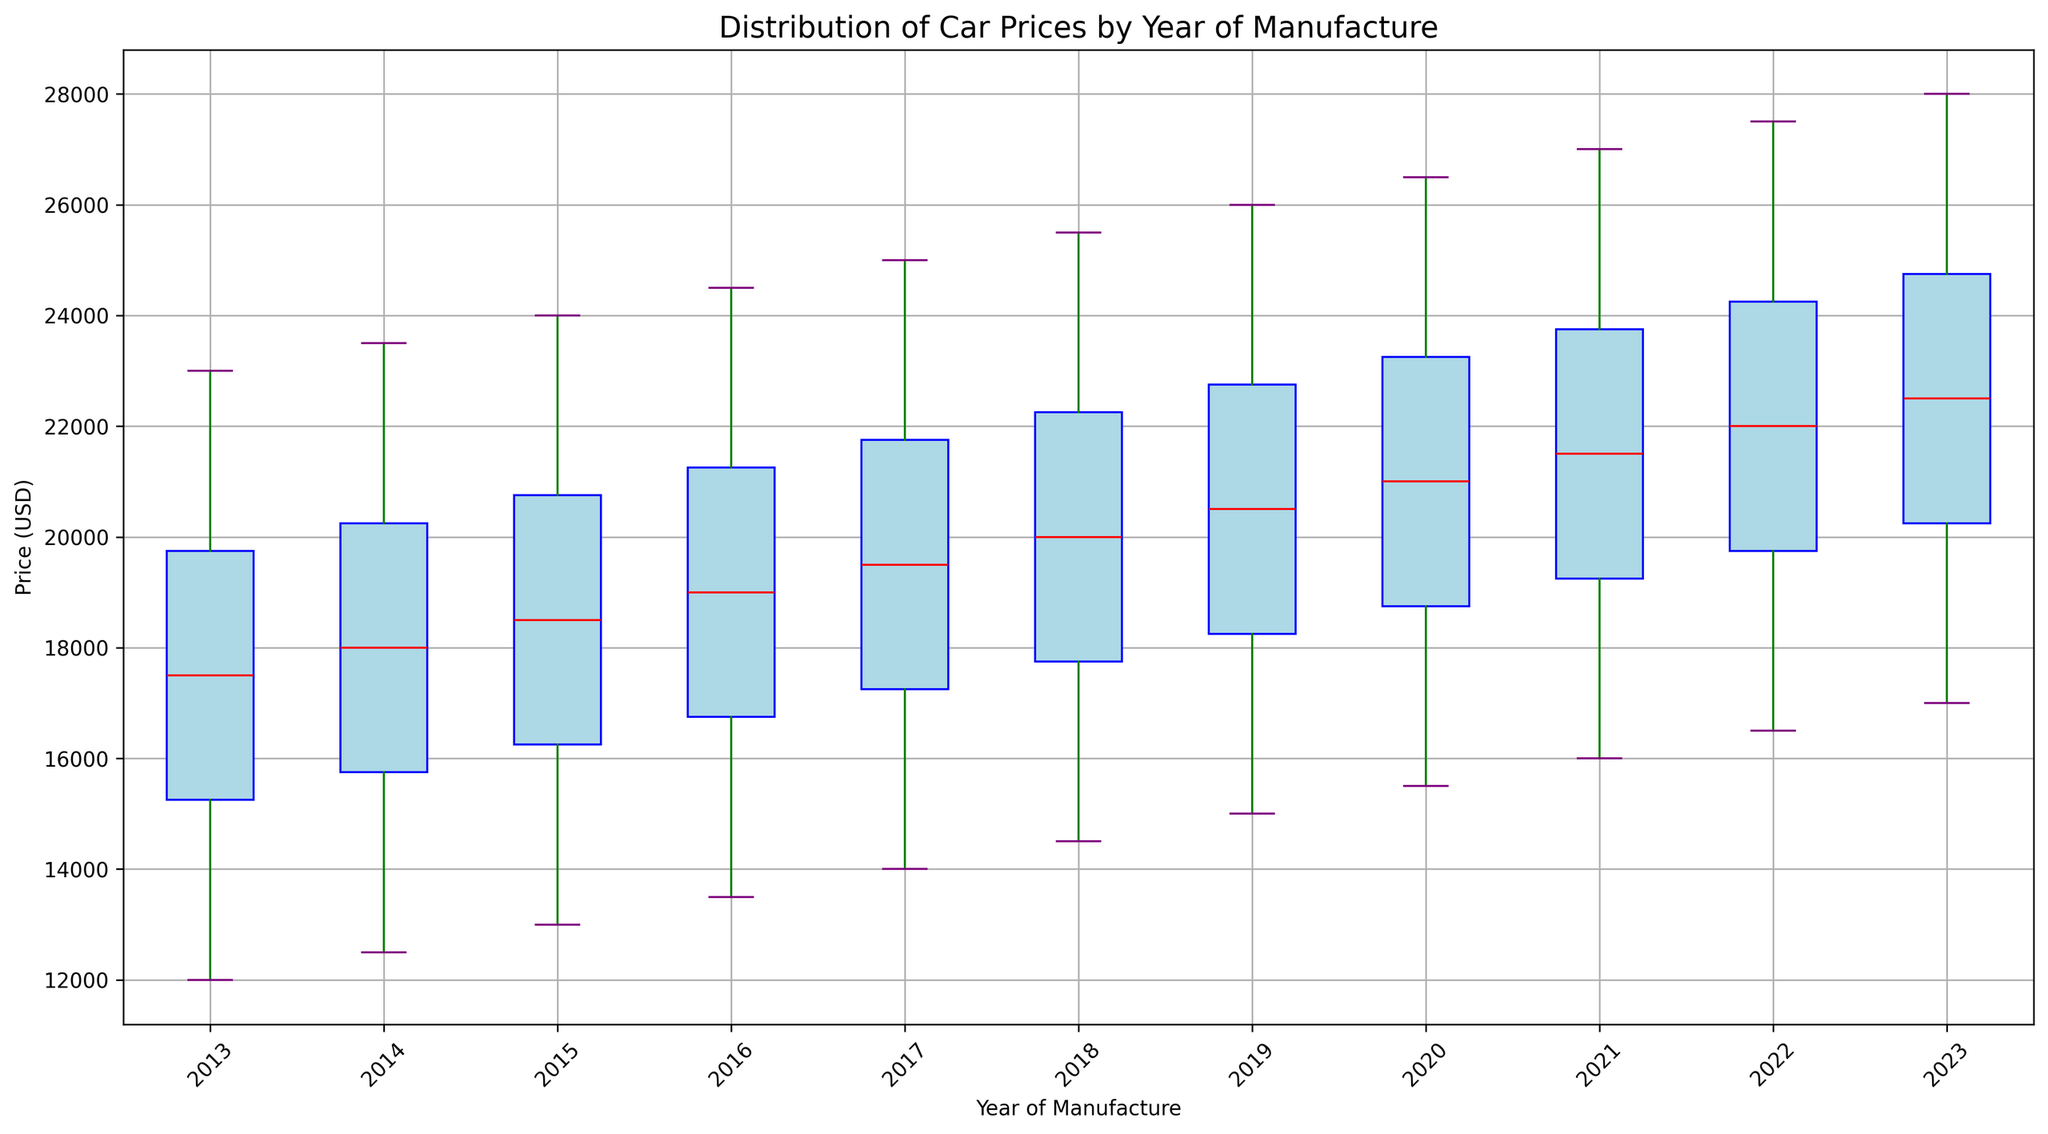What's the median car price for the year 2018? The median value is the middle value when the prices are arranged in ascending order. For 2018, the prices are [14500, 16500, 17500, 18500, 19500, 20500, 21500, 22500, 23500, 25500]. The middle values are 19500 and 20500, so the median is the average of these two: (19500 + 20500) / 2 = 20000
Answer: 20000 In which year is the median car price the highest? To determine the year with the highest median price, we need to compare the median prices of all years. From the box plot, we see that the median values increase each year, with 2023 having the highest median.
Answer: 2023 What is the range of car prices for the year 2015? The range is the difference between the maximum and minimum values. For 2015, the prices range from 13000 to 24000. So, the range is 24000 - 13000 = 11000
Answer: 11000 Which year has the smallest interquartile range (IQR) for car prices? The IQR is the difference between the third quartile (Q3) and the first quartile (Q1). Visually, the year with the smallest IQR will have the smallest box height. From the box plot, one can see that 2013 has the smallest IQR.
Answer: 2013 How does the median car price in 2022 compare to that in 2017? To compare the median prices, we find the medians for both years from the box plot. The median price for 2017 is 19000 and for 2022, it is 21500. The median price in 2022 is higher by 21500 - 19000 = 2500.
Answer: 2500 What is the difference between the maximum car prices in 2016 and 2020? From the box plot, the maximum prices for 2016 and 2020 are 24500 and 26500, respectively. The difference is 26500 - 24500 = 2000.
Answer: 2000 Identify the year with the highest variability in car prices. The variability can be assessed by looking at the range and spread of the box plot, including the whiskers and outliers. The year 2023 has the widest spread and variability.
Answer: 2023 Which year has the lowest median car price? From the box plot, we can identify the year with the lowest median by finding the lowest red line inside the boxes. The year with the lowest median car price is 2013.
Answer: 2013 What is the price difference between the first quartile (Q1) and the median in 2014? For 2014, the first quartile (Q1) is around 14500 and the median is 17500. The difference is 17500 - 14500 = 3000.
Answer: 3000 